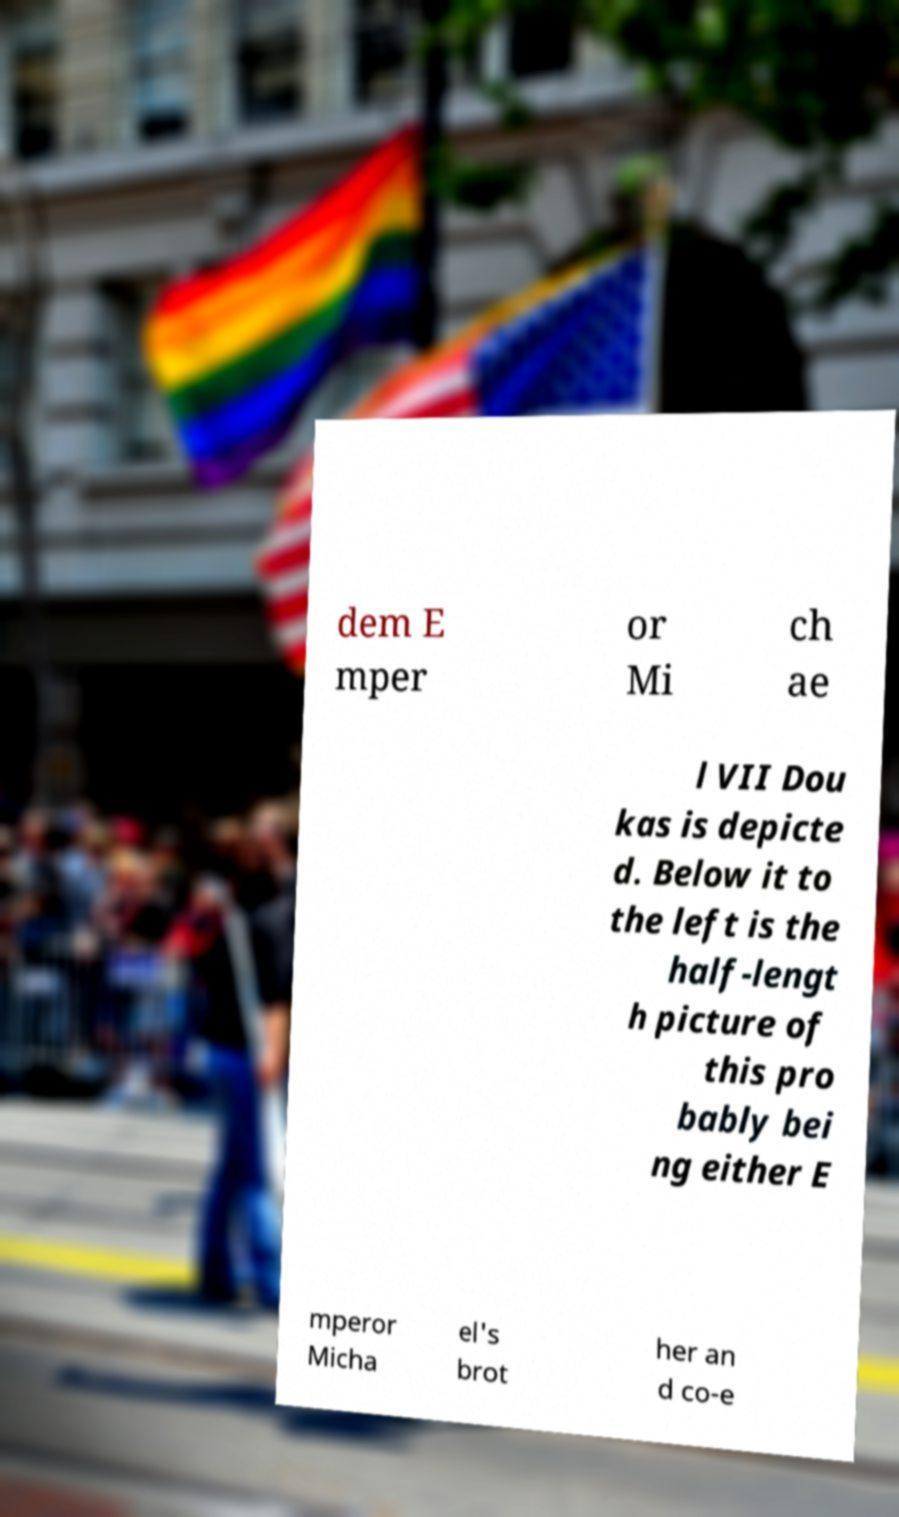Can you accurately transcribe the text from the provided image for me? dem E mper or Mi ch ae l VII Dou kas is depicte d. Below it to the left is the half-lengt h picture of this pro bably bei ng either E mperor Micha el's brot her an d co-e 